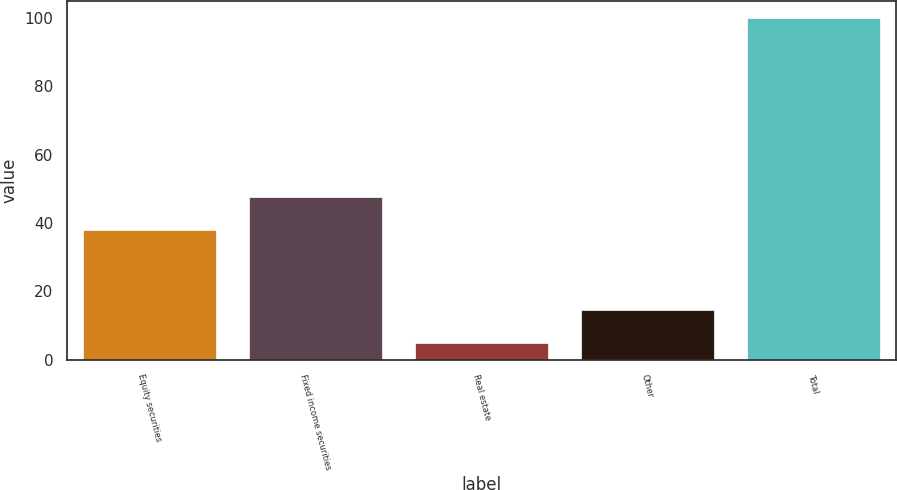Convert chart to OTSL. <chart><loc_0><loc_0><loc_500><loc_500><bar_chart><fcel>Equity securities<fcel>Fixed income securities<fcel>Real estate<fcel>Other<fcel>Total<nl><fcel>38<fcel>47.5<fcel>5<fcel>14.5<fcel>100<nl></chart> 